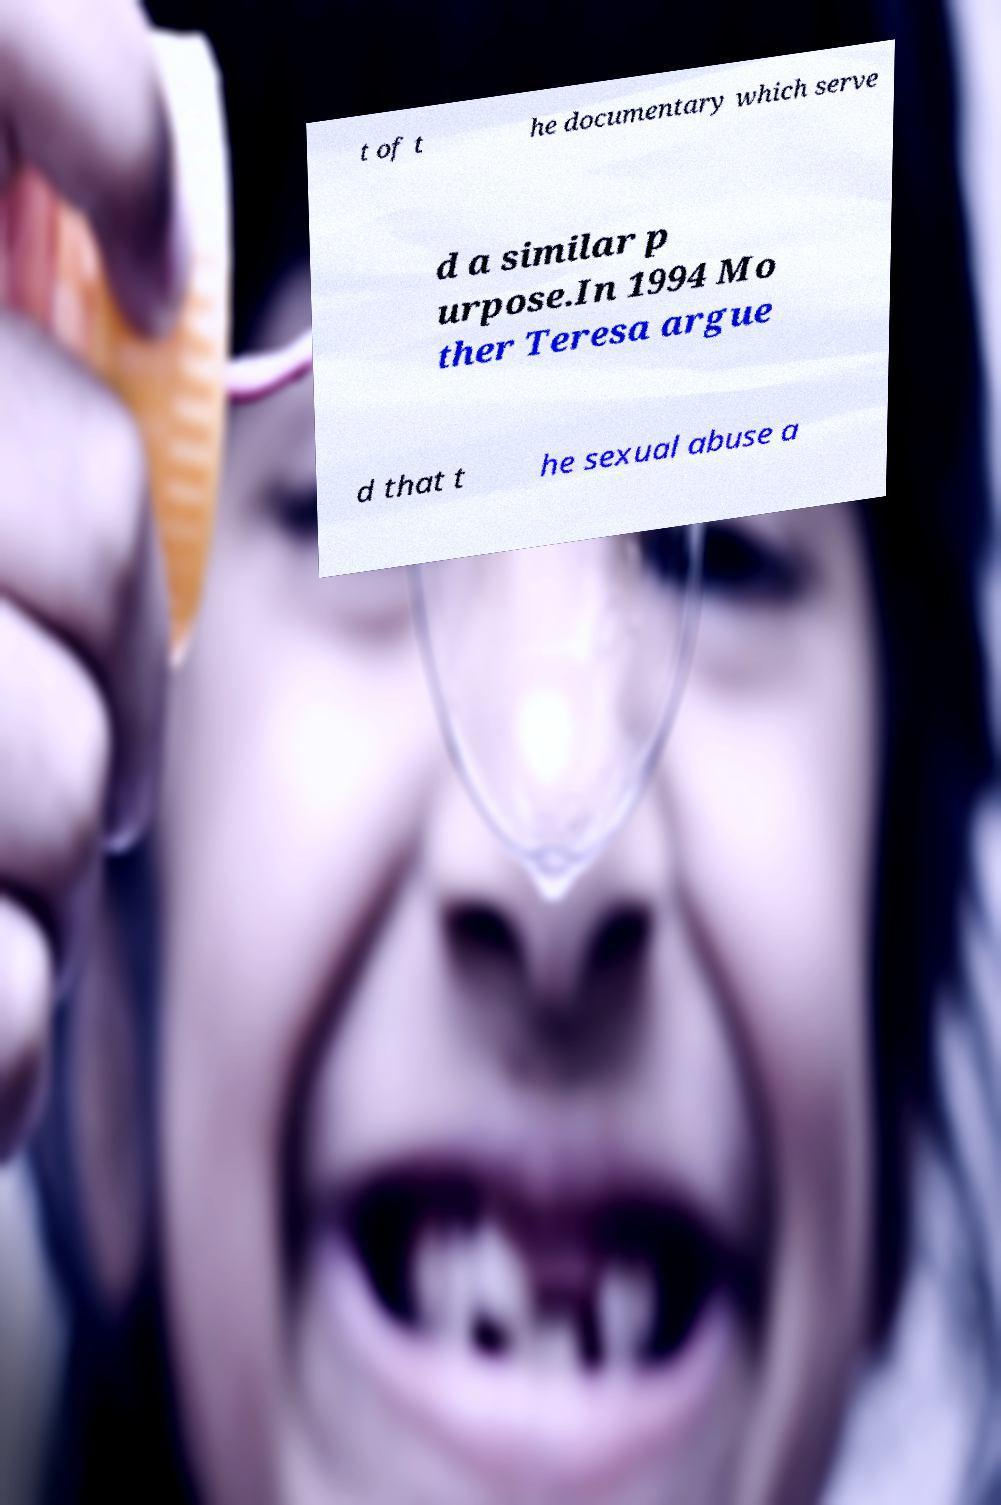Could you extract and type out the text from this image? t of t he documentary which serve d a similar p urpose.In 1994 Mo ther Teresa argue d that t he sexual abuse a 